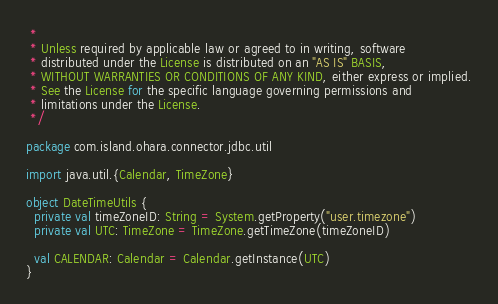Convert code to text. <code><loc_0><loc_0><loc_500><loc_500><_Scala_> *
 * Unless required by applicable law or agreed to in writing, software
 * distributed under the License is distributed on an "AS IS" BASIS,
 * WITHOUT WARRANTIES OR CONDITIONS OF ANY KIND, either express or implied.
 * See the License for the specific language governing permissions and
 * limitations under the License.
 */

package com.island.ohara.connector.jdbc.util

import java.util.{Calendar, TimeZone}

object DateTimeUtils {
  private val timeZoneID: String = System.getProperty("user.timezone")
  private val UTC: TimeZone = TimeZone.getTimeZone(timeZoneID)

  val CALENDAR: Calendar = Calendar.getInstance(UTC)
}
</code> 